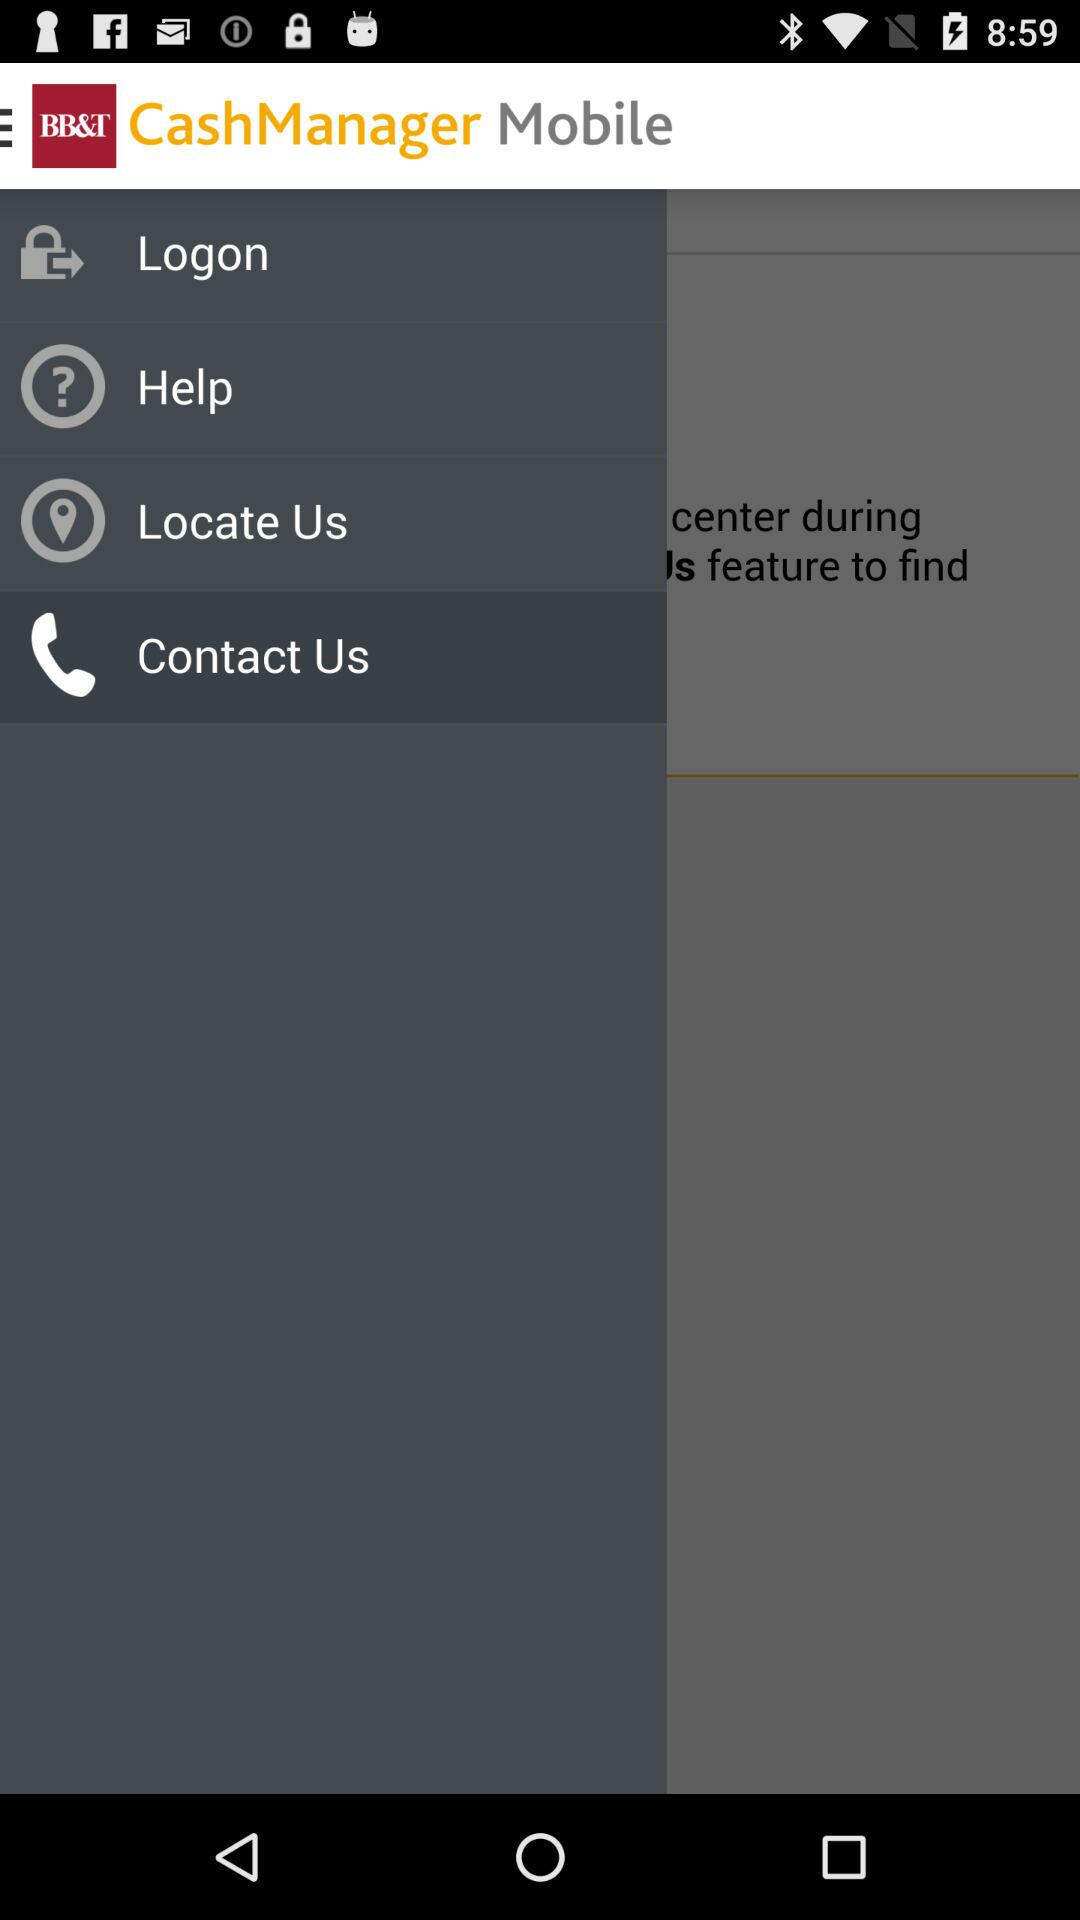What is the name of the application? The name of the application is "CashManager Mobile". 